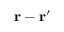Convert formula to latex. <formula><loc_0><loc_0><loc_500><loc_500>r - r ^ { \prime }</formula> 